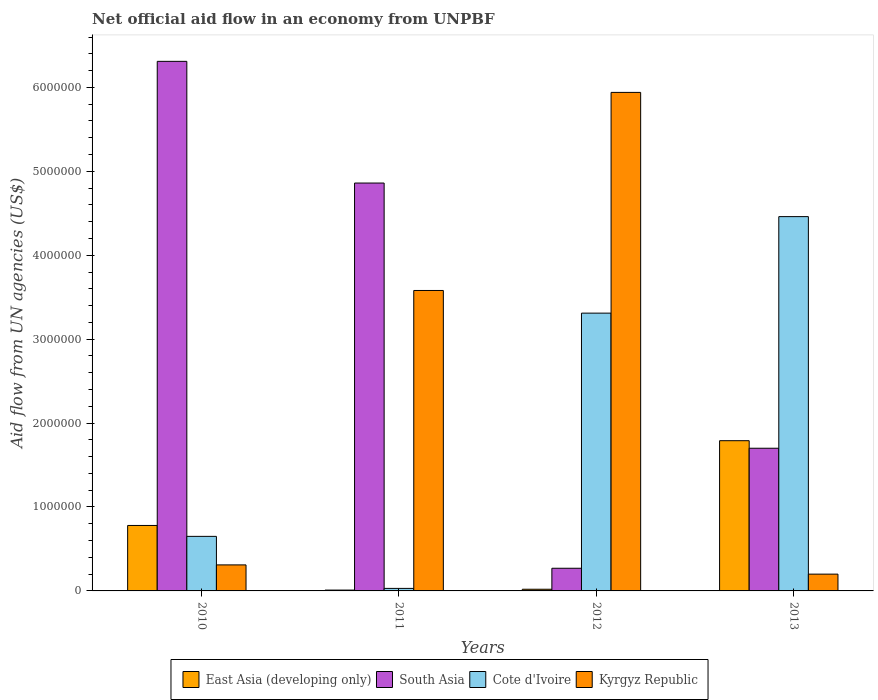How many different coloured bars are there?
Offer a terse response. 4. Are the number of bars on each tick of the X-axis equal?
Your answer should be compact. Yes. How many bars are there on the 2nd tick from the right?
Provide a succinct answer. 4. What is the label of the 4th group of bars from the left?
Give a very brief answer. 2013. What is the net official aid flow in East Asia (developing only) in 2012?
Offer a terse response. 2.00e+04. Across all years, what is the maximum net official aid flow in Kyrgyz Republic?
Give a very brief answer. 5.94e+06. Across all years, what is the minimum net official aid flow in East Asia (developing only)?
Your answer should be very brief. 10000. In which year was the net official aid flow in South Asia maximum?
Your answer should be compact. 2010. What is the total net official aid flow in Kyrgyz Republic in the graph?
Provide a succinct answer. 1.00e+07. What is the difference between the net official aid flow in South Asia in 2010 and that in 2013?
Provide a succinct answer. 4.61e+06. What is the average net official aid flow in South Asia per year?
Make the answer very short. 3.28e+06. In the year 2010, what is the difference between the net official aid flow in Cote d'Ivoire and net official aid flow in East Asia (developing only)?
Your answer should be very brief. -1.30e+05. In how many years, is the net official aid flow in South Asia greater than 3800000 US$?
Your response must be concise. 2. What is the ratio of the net official aid flow in South Asia in 2010 to that in 2011?
Provide a succinct answer. 1.3. What is the difference between the highest and the second highest net official aid flow in East Asia (developing only)?
Your response must be concise. 1.01e+06. What is the difference between the highest and the lowest net official aid flow in South Asia?
Give a very brief answer. 6.04e+06. In how many years, is the net official aid flow in South Asia greater than the average net official aid flow in South Asia taken over all years?
Offer a terse response. 2. Is it the case that in every year, the sum of the net official aid flow in Cote d'Ivoire and net official aid flow in East Asia (developing only) is greater than the sum of net official aid flow in South Asia and net official aid flow in Kyrgyz Republic?
Make the answer very short. No. What does the 1st bar from the left in 2012 represents?
Provide a short and direct response. East Asia (developing only). What does the 3rd bar from the right in 2011 represents?
Your answer should be compact. South Asia. How many bars are there?
Offer a very short reply. 16. What is the difference between two consecutive major ticks on the Y-axis?
Your answer should be compact. 1.00e+06. Does the graph contain any zero values?
Provide a succinct answer. No. What is the title of the graph?
Give a very brief answer. Net official aid flow in an economy from UNPBF. Does "Romania" appear as one of the legend labels in the graph?
Your response must be concise. No. What is the label or title of the X-axis?
Offer a very short reply. Years. What is the label or title of the Y-axis?
Keep it short and to the point. Aid flow from UN agencies (US$). What is the Aid flow from UN agencies (US$) of East Asia (developing only) in 2010?
Offer a very short reply. 7.80e+05. What is the Aid flow from UN agencies (US$) in South Asia in 2010?
Your answer should be very brief. 6.31e+06. What is the Aid flow from UN agencies (US$) of Cote d'Ivoire in 2010?
Offer a very short reply. 6.50e+05. What is the Aid flow from UN agencies (US$) in Kyrgyz Republic in 2010?
Make the answer very short. 3.10e+05. What is the Aid flow from UN agencies (US$) in East Asia (developing only) in 2011?
Your answer should be compact. 10000. What is the Aid flow from UN agencies (US$) in South Asia in 2011?
Your answer should be very brief. 4.86e+06. What is the Aid flow from UN agencies (US$) of Cote d'Ivoire in 2011?
Ensure brevity in your answer.  3.00e+04. What is the Aid flow from UN agencies (US$) in Kyrgyz Republic in 2011?
Your answer should be very brief. 3.58e+06. What is the Aid flow from UN agencies (US$) of East Asia (developing only) in 2012?
Provide a short and direct response. 2.00e+04. What is the Aid flow from UN agencies (US$) of South Asia in 2012?
Your answer should be very brief. 2.70e+05. What is the Aid flow from UN agencies (US$) of Cote d'Ivoire in 2012?
Ensure brevity in your answer.  3.31e+06. What is the Aid flow from UN agencies (US$) of Kyrgyz Republic in 2012?
Your answer should be compact. 5.94e+06. What is the Aid flow from UN agencies (US$) of East Asia (developing only) in 2013?
Give a very brief answer. 1.79e+06. What is the Aid flow from UN agencies (US$) in South Asia in 2013?
Offer a very short reply. 1.70e+06. What is the Aid flow from UN agencies (US$) of Cote d'Ivoire in 2013?
Offer a terse response. 4.46e+06. What is the Aid flow from UN agencies (US$) of Kyrgyz Republic in 2013?
Give a very brief answer. 2.00e+05. Across all years, what is the maximum Aid flow from UN agencies (US$) in East Asia (developing only)?
Make the answer very short. 1.79e+06. Across all years, what is the maximum Aid flow from UN agencies (US$) in South Asia?
Provide a succinct answer. 6.31e+06. Across all years, what is the maximum Aid flow from UN agencies (US$) in Cote d'Ivoire?
Ensure brevity in your answer.  4.46e+06. Across all years, what is the maximum Aid flow from UN agencies (US$) of Kyrgyz Republic?
Your answer should be compact. 5.94e+06. Across all years, what is the minimum Aid flow from UN agencies (US$) of East Asia (developing only)?
Offer a very short reply. 10000. Across all years, what is the minimum Aid flow from UN agencies (US$) of South Asia?
Your answer should be very brief. 2.70e+05. Across all years, what is the minimum Aid flow from UN agencies (US$) in Cote d'Ivoire?
Your response must be concise. 3.00e+04. Across all years, what is the minimum Aid flow from UN agencies (US$) of Kyrgyz Republic?
Offer a terse response. 2.00e+05. What is the total Aid flow from UN agencies (US$) of East Asia (developing only) in the graph?
Make the answer very short. 2.60e+06. What is the total Aid flow from UN agencies (US$) of South Asia in the graph?
Your response must be concise. 1.31e+07. What is the total Aid flow from UN agencies (US$) in Cote d'Ivoire in the graph?
Make the answer very short. 8.45e+06. What is the total Aid flow from UN agencies (US$) in Kyrgyz Republic in the graph?
Your response must be concise. 1.00e+07. What is the difference between the Aid flow from UN agencies (US$) in East Asia (developing only) in 2010 and that in 2011?
Ensure brevity in your answer.  7.70e+05. What is the difference between the Aid flow from UN agencies (US$) of South Asia in 2010 and that in 2011?
Offer a terse response. 1.45e+06. What is the difference between the Aid flow from UN agencies (US$) in Cote d'Ivoire in 2010 and that in 2011?
Provide a succinct answer. 6.20e+05. What is the difference between the Aid flow from UN agencies (US$) of Kyrgyz Republic in 2010 and that in 2011?
Keep it short and to the point. -3.27e+06. What is the difference between the Aid flow from UN agencies (US$) of East Asia (developing only) in 2010 and that in 2012?
Give a very brief answer. 7.60e+05. What is the difference between the Aid flow from UN agencies (US$) of South Asia in 2010 and that in 2012?
Offer a very short reply. 6.04e+06. What is the difference between the Aid flow from UN agencies (US$) in Cote d'Ivoire in 2010 and that in 2012?
Your answer should be compact. -2.66e+06. What is the difference between the Aid flow from UN agencies (US$) of Kyrgyz Republic in 2010 and that in 2012?
Ensure brevity in your answer.  -5.63e+06. What is the difference between the Aid flow from UN agencies (US$) in East Asia (developing only) in 2010 and that in 2013?
Ensure brevity in your answer.  -1.01e+06. What is the difference between the Aid flow from UN agencies (US$) of South Asia in 2010 and that in 2013?
Your response must be concise. 4.61e+06. What is the difference between the Aid flow from UN agencies (US$) in Cote d'Ivoire in 2010 and that in 2013?
Provide a short and direct response. -3.81e+06. What is the difference between the Aid flow from UN agencies (US$) of Kyrgyz Republic in 2010 and that in 2013?
Keep it short and to the point. 1.10e+05. What is the difference between the Aid flow from UN agencies (US$) of East Asia (developing only) in 2011 and that in 2012?
Offer a terse response. -10000. What is the difference between the Aid flow from UN agencies (US$) of South Asia in 2011 and that in 2012?
Give a very brief answer. 4.59e+06. What is the difference between the Aid flow from UN agencies (US$) in Cote d'Ivoire in 2011 and that in 2012?
Your answer should be very brief. -3.28e+06. What is the difference between the Aid flow from UN agencies (US$) of Kyrgyz Republic in 2011 and that in 2012?
Ensure brevity in your answer.  -2.36e+06. What is the difference between the Aid flow from UN agencies (US$) in East Asia (developing only) in 2011 and that in 2013?
Provide a succinct answer. -1.78e+06. What is the difference between the Aid flow from UN agencies (US$) in South Asia in 2011 and that in 2013?
Provide a succinct answer. 3.16e+06. What is the difference between the Aid flow from UN agencies (US$) in Cote d'Ivoire in 2011 and that in 2013?
Make the answer very short. -4.43e+06. What is the difference between the Aid flow from UN agencies (US$) of Kyrgyz Republic in 2011 and that in 2013?
Your response must be concise. 3.38e+06. What is the difference between the Aid flow from UN agencies (US$) of East Asia (developing only) in 2012 and that in 2013?
Ensure brevity in your answer.  -1.77e+06. What is the difference between the Aid flow from UN agencies (US$) in South Asia in 2012 and that in 2013?
Keep it short and to the point. -1.43e+06. What is the difference between the Aid flow from UN agencies (US$) in Cote d'Ivoire in 2012 and that in 2013?
Give a very brief answer. -1.15e+06. What is the difference between the Aid flow from UN agencies (US$) in Kyrgyz Republic in 2012 and that in 2013?
Give a very brief answer. 5.74e+06. What is the difference between the Aid flow from UN agencies (US$) of East Asia (developing only) in 2010 and the Aid flow from UN agencies (US$) of South Asia in 2011?
Provide a succinct answer. -4.08e+06. What is the difference between the Aid flow from UN agencies (US$) of East Asia (developing only) in 2010 and the Aid flow from UN agencies (US$) of Cote d'Ivoire in 2011?
Keep it short and to the point. 7.50e+05. What is the difference between the Aid flow from UN agencies (US$) of East Asia (developing only) in 2010 and the Aid flow from UN agencies (US$) of Kyrgyz Republic in 2011?
Your answer should be compact. -2.80e+06. What is the difference between the Aid flow from UN agencies (US$) in South Asia in 2010 and the Aid flow from UN agencies (US$) in Cote d'Ivoire in 2011?
Offer a terse response. 6.28e+06. What is the difference between the Aid flow from UN agencies (US$) of South Asia in 2010 and the Aid flow from UN agencies (US$) of Kyrgyz Republic in 2011?
Your response must be concise. 2.73e+06. What is the difference between the Aid flow from UN agencies (US$) of Cote d'Ivoire in 2010 and the Aid flow from UN agencies (US$) of Kyrgyz Republic in 2011?
Your response must be concise. -2.93e+06. What is the difference between the Aid flow from UN agencies (US$) in East Asia (developing only) in 2010 and the Aid flow from UN agencies (US$) in South Asia in 2012?
Offer a very short reply. 5.10e+05. What is the difference between the Aid flow from UN agencies (US$) of East Asia (developing only) in 2010 and the Aid flow from UN agencies (US$) of Cote d'Ivoire in 2012?
Your answer should be compact. -2.53e+06. What is the difference between the Aid flow from UN agencies (US$) in East Asia (developing only) in 2010 and the Aid flow from UN agencies (US$) in Kyrgyz Republic in 2012?
Your answer should be very brief. -5.16e+06. What is the difference between the Aid flow from UN agencies (US$) of South Asia in 2010 and the Aid flow from UN agencies (US$) of Cote d'Ivoire in 2012?
Give a very brief answer. 3.00e+06. What is the difference between the Aid flow from UN agencies (US$) in Cote d'Ivoire in 2010 and the Aid flow from UN agencies (US$) in Kyrgyz Republic in 2012?
Offer a terse response. -5.29e+06. What is the difference between the Aid flow from UN agencies (US$) of East Asia (developing only) in 2010 and the Aid flow from UN agencies (US$) of South Asia in 2013?
Give a very brief answer. -9.20e+05. What is the difference between the Aid flow from UN agencies (US$) of East Asia (developing only) in 2010 and the Aid flow from UN agencies (US$) of Cote d'Ivoire in 2013?
Provide a short and direct response. -3.68e+06. What is the difference between the Aid flow from UN agencies (US$) in East Asia (developing only) in 2010 and the Aid flow from UN agencies (US$) in Kyrgyz Republic in 2013?
Ensure brevity in your answer.  5.80e+05. What is the difference between the Aid flow from UN agencies (US$) in South Asia in 2010 and the Aid flow from UN agencies (US$) in Cote d'Ivoire in 2013?
Offer a very short reply. 1.85e+06. What is the difference between the Aid flow from UN agencies (US$) of South Asia in 2010 and the Aid flow from UN agencies (US$) of Kyrgyz Republic in 2013?
Offer a very short reply. 6.11e+06. What is the difference between the Aid flow from UN agencies (US$) in Cote d'Ivoire in 2010 and the Aid flow from UN agencies (US$) in Kyrgyz Republic in 2013?
Ensure brevity in your answer.  4.50e+05. What is the difference between the Aid flow from UN agencies (US$) of East Asia (developing only) in 2011 and the Aid flow from UN agencies (US$) of Cote d'Ivoire in 2012?
Your answer should be compact. -3.30e+06. What is the difference between the Aid flow from UN agencies (US$) in East Asia (developing only) in 2011 and the Aid flow from UN agencies (US$) in Kyrgyz Republic in 2012?
Your answer should be compact. -5.93e+06. What is the difference between the Aid flow from UN agencies (US$) in South Asia in 2011 and the Aid flow from UN agencies (US$) in Cote d'Ivoire in 2012?
Offer a terse response. 1.55e+06. What is the difference between the Aid flow from UN agencies (US$) of South Asia in 2011 and the Aid flow from UN agencies (US$) of Kyrgyz Republic in 2012?
Provide a succinct answer. -1.08e+06. What is the difference between the Aid flow from UN agencies (US$) in Cote d'Ivoire in 2011 and the Aid flow from UN agencies (US$) in Kyrgyz Republic in 2012?
Give a very brief answer. -5.91e+06. What is the difference between the Aid flow from UN agencies (US$) in East Asia (developing only) in 2011 and the Aid flow from UN agencies (US$) in South Asia in 2013?
Ensure brevity in your answer.  -1.69e+06. What is the difference between the Aid flow from UN agencies (US$) in East Asia (developing only) in 2011 and the Aid flow from UN agencies (US$) in Cote d'Ivoire in 2013?
Make the answer very short. -4.45e+06. What is the difference between the Aid flow from UN agencies (US$) in East Asia (developing only) in 2011 and the Aid flow from UN agencies (US$) in Kyrgyz Republic in 2013?
Give a very brief answer. -1.90e+05. What is the difference between the Aid flow from UN agencies (US$) of South Asia in 2011 and the Aid flow from UN agencies (US$) of Cote d'Ivoire in 2013?
Provide a succinct answer. 4.00e+05. What is the difference between the Aid flow from UN agencies (US$) in South Asia in 2011 and the Aid flow from UN agencies (US$) in Kyrgyz Republic in 2013?
Ensure brevity in your answer.  4.66e+06. What is the difference between the Aid flow from UN agencies (US$) in East Asia (developing only) in 2012 and the Aid flow from UN agencies (US$) in South Asia in 2013?
Make the answer very short. -1.68e+06. What is the difference between the Aid flow from UN agencies (US$) in East Asia (developing only) in 2012 and the Aid flow from UN agencies (US$) in Cote d'Ivoire in 2013?
Your answer should be compact. -4.44e+06. What is the difference between the Aid flow from UN agencies (US$) of South Asia in 2012 and the Aid flow from UN agencies (US$) of Cote d'Ivoire in 2013?
Give a very brief answer. -4.19e+06. What is the difference between the Aid flow from UN agencies (US$) in South Asia in 2012 and the Aid flow from UN agencies (US$) in Kyrgyz Republic in 2013?
Provide a short and direct response. 7.00e+04. What is the difference between the Aid flow from UN agencies (US$) in Cote d'Ivoire in 2012 and the Aid flow from UN agencies (US$) in Kyrgyz Republic in 2013?
Provide a short and direct response. 3.11e+06. What is the average Aid flow from UN agencies (US$) in East Asia (developing only) per year?
Your answer should be very brief. 6.50e+05. What is the average Aid flow from UN agencies (US$) of South Asia per year?
Offer a terse response. 3.28e+06. What is the average Aid flow from UN agencies (US$) of Cote d'Ivoire per year?
Your answer should be compact. 2.11e+06. What is the average Aid flow from UN agencies (US$) in Kyrgyz Republic per year?
Your answer should be very brief. 2.51e+06. In the year 2010, what is the difference between the Aid flow from UN agencies (US$) of East Asia (developing only) and Aid flow from UN agencies (US$) of South Asia?
Your answer should be compact. -5.53e+06. In the year 2010, what is the difference between the Aid flow from UN agencies (US$) in East Asia (developing only) and Aid flow from UN agencies (US$) in Cote d'Ivoire?
Your response must be concise. 1.30e+05. In the year 2010, what is the difference between the Aid flow from UN agencies (US$) of East Asia (developing only) and Aid flow from UN agencies (US$) of Kyrgyz Republic?
Your answer should be very brief. 4.70e+05. In the year 2010, what is the difference between the Aid flow from UN agencies (US$) of South Asia and Aid flow from UN agencies (US$) of Cote d'Ivoire?
Your response must be concise. 5.66e+06. In the year 2010, what is the difference between the Aid flow from UN agencies (US$) of South Asia and Aid flow from UN agencies (US$) of Kyrgyz Republic?
Ensure brevity in your answer.  6.00e+06. In the year 2011, what is the difference between the Aid flow from UN agencies (US$) in East Asia (developing only) and Aid flow from UN agencies (US$) in South Asia?
Your response must be concise. -4.85e+06. In the year 2011, what is the difference between the Aid flow from UN agencies (US$) of East Asia (developing only) and Aid flow from UN agencies (US$) of Cote d'Ivoire?
Keep it short and to the point. -2.00e+04. In the year 2011, what is the difference between the Aid flow from UN agencies (US$) in East Asia (developing only) and Aid flow from UN agencies (US$) in Kyrgyz Republic?
Give a very brief answer. -3.57e+06. In the year 2011, what is the difference between the Aid flow from UN agencies (US$) of South Asia and Aid flow from UN agencies (US$) of Cote d'Ivoire?
Offer a terse response. 4.83e+06. In the year 2011, what is the difference between the Aid flow from UN agencies (US$) in South Asia and Aid flow from UN agencies (US$) in Kyrgyz Republic?
Ensure brevity in your answer.  1.28e+06. In the year 2011, what is the difference between the Aid flow from UN agencies (US$) in Cote d'Ivoire and Aid flow from UN agencies (US$) in Kyrgyz Republic?
Your response must be concise. -3.55e+06. In the year 2012, what is the difference between the Aid flow from UN agencies (US$) in East Asia (developing only) and Aid flow from UN agencies (US$) in South Asia?
Provide a short and direct response. -2.50e+05. In the year 2012, what is the difference between the Aid flow from UN agencies (US$) in East Asia (developing only) and Aid flow from UN agencies (US$) in Cote d'Ivoire?
Offer a terse response. -3.29e+06. In the year 2012, what is the difference between the Aid flow from UN agencies (US$) of East Asia (developing only) and Aid flow from UN agencies (US$) of Kyrgyz Republic?
Your response must be concise. -5.92e+06. In the year 2012, what is the difference between the Aid flow from UN agencies (US$) of South Asia and Aid flow from UN agencies (US$) of Cote d'Ivoire?
Give a very brief answer. -3.04e+06. In the year 2012, what is the difference between the Aid flow from UN agencies (US$) of South Asia and Aid flow from UN agencies (US$) of Kyrgyz Republic?
Your answer should be compact. -5.67e+06. In the year 2012, what is the difference between the Aid flow from UN agencies (US$) of Cote d'Ivoire and Aid flow from UN agencies (US$) of Kyrgyz Republic?
Give a very brief answer. -2.63e+06. In the year 2013, what is the difference between the Aid flow from UN agencies (US$) in East Asia (developing only) and Aid flow from UN agencies (US$) in South Asia?
Offer a terse response. 9.00e+04. In the year 2013, what is the difference between the Aid flow from UN agencies (US$) in East Asia (developing only) and Aid flow from UN agencies (US$) in Cote d'Ivoire?
Make the answer very short. -2.67e+06. In the year 2013, what is the difference between the Aid flow from UN agencies (US$) in East Asia (developing only) and Aid flow from UN agencies (US$) in Kyrgyz Republic?
Provide a succinct answer. 1.59e+06. In the year 2013, what is the difference between the Aid flow from UN agencies (US$) in South Asia and Aid flow from UN agencies (US$) in Cote d'Ivoire?
Keep it short and to the point. -2.76e+06. In the year 2013, what is the difference between the Aid flow from UN agencies (US$) in South Asia and Aid flow from UN agencies (US$) in Kyrgyz Republic?
Your response must be concise. 1.50e+06. In the year 2013, what is the difference between the Aid flow from UN agencies (US$) of Cote d'Ivoire and Aid flow from UN agencies (US$) of Kyrgyz Republic?
Your answer should be very brief. 4.26e+06. What is the ratio of the Aid flow from UN agencies (US$) of East Asia (developing only) in 2010 to that in 2011?
Make the answer very short. 78. What is the ratio of the Aid flow from UN agencies (US$) in South Asia in 2010 to that in 2011?
Ensure brevity in your answer.  1.3. What is the ratio of the Aid flow from UN agencies (US$) of Cote d'Ivoire in 2010 to that in 2011?
Keep it short and to the point. 21.67. What is the ratio of the Aid flow from UN agencies (US$) of Kyrgyz Republic in 2010 to that in 2011?
Provide a succinct answer. 0.09. What is the ratio of the Aid flow from UN agencies (US$) of East Asia (developing only) in 2010 to that in 2012?
Keep it short and to the point. 39. What is the ratio of the Aid flow from UN agencies (US$) of South Asia in 2010 to that in 2012?
Keep it short and to the point. 23.37. What is the ratio of the Aid flow from UN agencies (US$) in Cote d'Ivoire in 2010 to that in 2012?
Your answer should be very brief. 0.2. What is the ratio of the Aid flow from UN agencies (US$) of Kyrgyz Republic in 2010 to that in 2012?
Your answer should be compact. 0.05. What is the ratio of the Aid flow from UN agencies (US$) in East Asia (developing only) in 2010 to that in 2013?
Keep it short and to the point. 0.44. What is the ratio of the Aid flow from UN agencies (US$) of South Asia in 2010 to that in 2013?
Your answer should be compact. 3.71. What is the ratio of the Aid flow from UN agencies (US$) in Cote d'Ivoire in 2010 to that in 2013?
Your answer should be compact. 0.15. What is the ratio of the Aid flow from UN agencies (US$) of Kyrgyz Republic in 2010 to that in 2013?
Your answer should be compact. 1.55. What is the ratio of the Aid flow from UN agencies (US$) of Cote d'Ivoire in 2011 to that in 2012?
Provide a short and direct response. 0.01. What is the ratio of the Aid flow from UN agencies (US$) of Kyrgyz Republic in 2011 to that in 2012?
Make the answer very short. 0.6. What is the ratio of the Aid flow from UN agencies (US$) of East Asia (developing only) in 2011 to that in 2013?
Give a very brief answer. 0.01. What is the ratio of the Aid flow from UN agencies (US$) of South Asia in 2011 to that in 2013?
Your answer should be compact. 2.86. What is the ratio of the Aid flow from UN agencies (US$) of Cote d'Ivoire in 2011 to that in 2013?
Ensure brevity in your answer.  0.01. What is the ratio of the Aid flow from UN agencies (US$) in East Asia (developing only) in 2012 to that in 2013?
Provide a short and direct response. 0.01. What is the ratio of the Aid flow from UN agencies (US$) in South Asia in 2012 to that in 2013?
Keep it short and to the point. 0.16. What is the ratio of the Aid flow from UN agencies (US$) in Cote d'Ivoire in 2012 to that in 2013?
Your response must be concise. 0.74. What is the ratio of the Aid flow from UN agencies (US$) in Kyrgyz Republic in 2012 to that in 2013?
Your answer should be very brief. 29.7. What is the difference between the highest and the second highest Aid flow from UN agencies (US$) of East Asia (developing only)?
Give a very brief answer. 1.01e+06. What is the difference between the highest and the second highest Aid flow from UN agencies (US$) of South Asia?
Provide a succinct answer. 1.45e+06. What is the difference between the highest and the second highest Aid flow from UN agencies (US$) in Cote d'Ivoire?
Make the answer very short. 1.15e+06. What is the difference between the highest and the second highest Aid flow from UN agencies (US$) in Kyrgyz Republic?
Give a very brief answer. 2.36e+06. What is the difference between the highest and the lowest Aid flow from UN agencies (US$) in East Asia (developing only)?
Offer a terse response. 1.78e+06. What is the difference between the highest and the lowest Aid flow from UN agencies (US$) in South Asia?
Offer a very short reply. 6.04e+06. What is the difference between the highest and the lowest Aid flow from UN agencies (US$) in Cote d'Ivoire?
Offer a very short reply. 4.43e+06. What is the difference between the highest and the lowest Aid flow from UN agencies (US$) of Kyrgyz Republic?
Keep it short and to the point. 5.74e+06. 